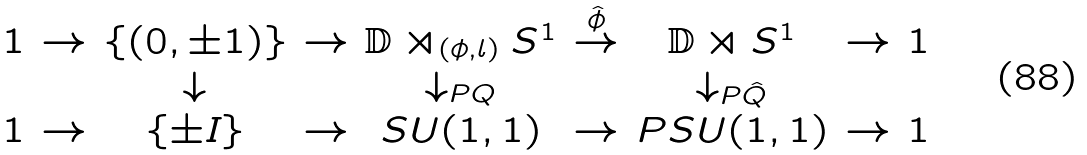Convert formula to latex. <formula><loc_0><loc_0><loc_500><loc_500>\begin{array} { c c c c c c c c c } 1 & \rightarrow & \{ ( 0 , \pm 1 ) \} & \rightarrow & \mathbb { D } \rtimes _ { ( \phi , l ) } S ^ { 1 } & \overset { \hat { \phi } } { \rightarrow } & \mathbb { D } \rtimes S ^ { 1 } & \rightarrow & 1 \\ & & \downarrow & & \downarrow _ { P Q } & & \downarrow _ { P \hat { Q } } & & \\ 1 & \rightarrow & \{ \pm I \} & \rightarrow & S U ( 1 , 1 ) & \rightarrow & P S U ( 1 , 1 ) & \rightarrow & 1 \end{array}</formula> 